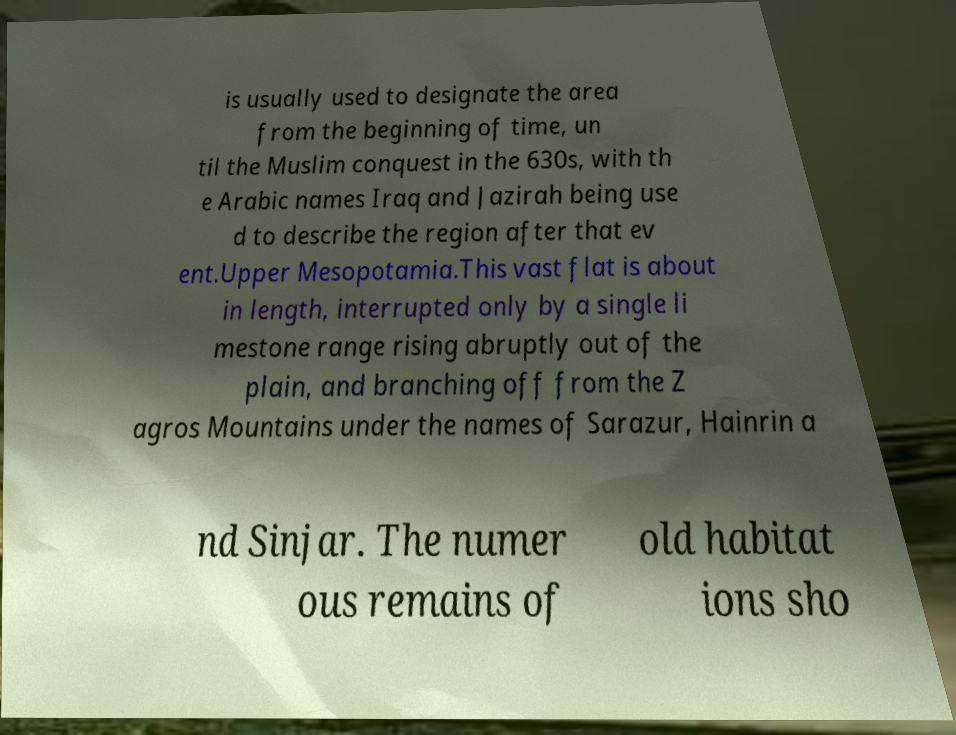For documentation purposes, I need the text within this image transcribed. Could you provide that? is usually used to designate the area from the beginning of time, un til the Muslim conquest in the 630s, with th e Arabic names Iraq and Jazirah being use d to describe the region after that ev ent.Upper Mesopotamia.This vast flat is about in length, interrupted only by a single li mestone range rising abruptly out of the plain, and branching off from the Z agros Mountains under the names of Sarazur, Hainrin a nd Sinjar. The numer ous remains of old habitat ions sho 